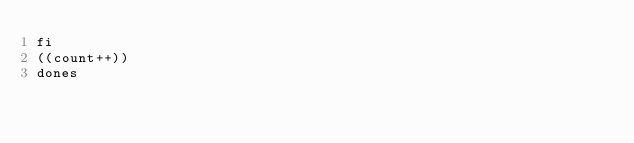<code> <loc_0><loc_0><loc_500><loc_500><_Bash_>fi
((count++))
dones
</code> 